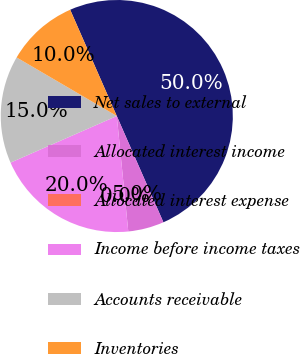Convert chart. <chart><loc_0><loc_0><loc_500><loc_500><pie_chart><fcel>Net sales to external<fcel>Allocated interest income<fcel>Allocated interest expense<fcel>Income before income taxes<fcel>Accounts receivable<fcel>Inventories<nl><fcel>50.0%<fcel>5.0%<fcel>0.0%<fcel>20.0%<fcel>15.0%<fcel>10.0%<nl></chart> 